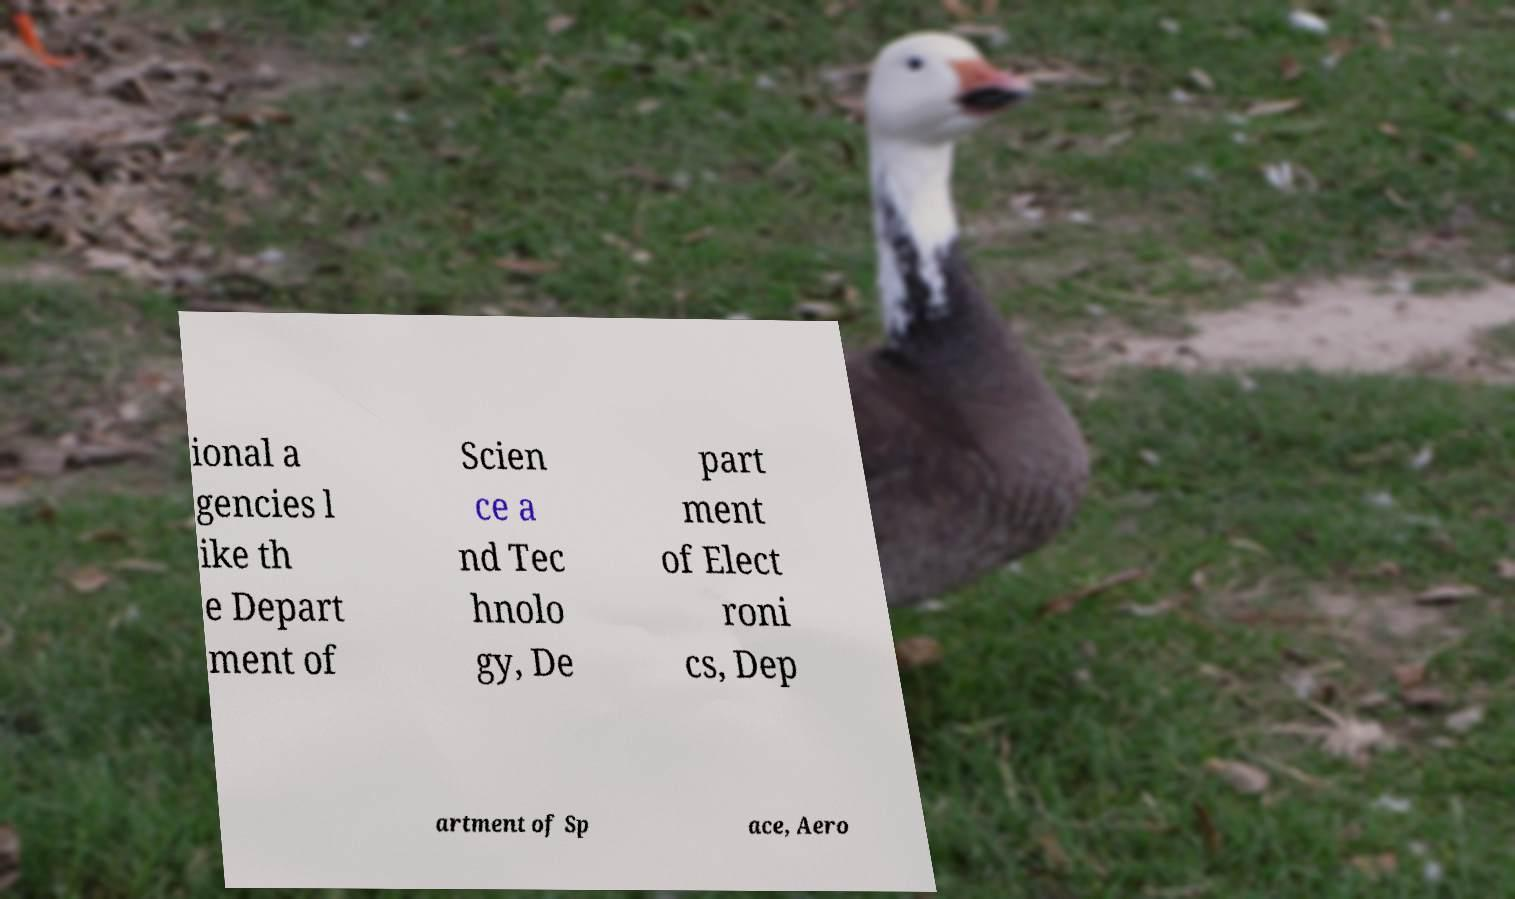Could you extract and type out the text from this image? ional a gencies l ike th e Depart ment of Scien ce a nd Tec hnolo gy, De part ment of Elect roni cs, Dep artment of Sp ace, Aero 